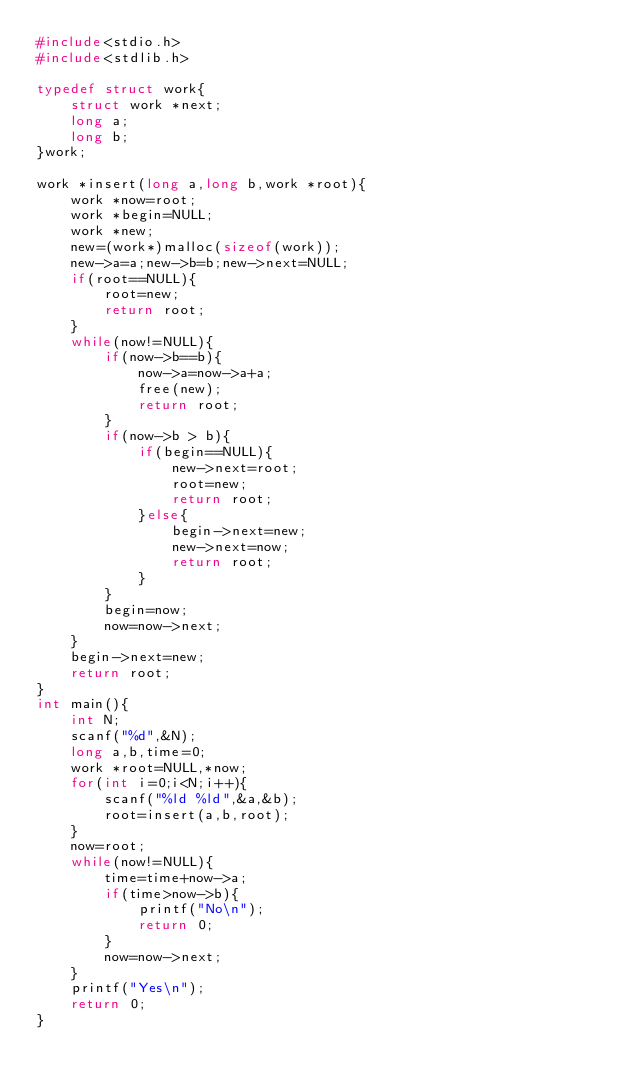Convert code to text. <code><loc_0><loc_0><loc_500><loc_500><_C_>#include<stdio.h>
#include<stdlib.h>

typedef struct work{
    struct work *next;
    long a;
    long b;
}work;

work *insert(long a,long b,work *root){
    work *now=root;
    work *begin=NULL;
    work *new;
    new=(work*)malloc(sizeof(work));
    new->a=a;new->b=b;new->next=NULL;
    if(root==NULL){
        root=new;
        return root;
    }
    while(now!=NULL){
        if(now->b==b){
            now->a=now->a+a;
            free(new);
            return root;
        }
        if(now->b > b){
            if(begin==NULL){
                new->next=root;
                root=new;
                return root;
            }else{
                begin->next=new;
                new->next=now;
                return root;
            }
        }
        begin=now;
        now=now->next;
    }
    begin->next=new;
    return root;
}
int main(){
    int N;
    scanf("%d",&N);
    long a,b,time=0;
    work *root=NULL,*now;
    for(int i=0;i<N;i++){
        scanf("%ld %ld",&a,&b);
        root=insert(a,b,root);
    }
    now=root;
    while(now!=NULL){
        time=time+now->a;
        if(time>now->b){
            printf("No\n");
            return 0;
        }
        now=now->next;
    }
    printf("Yes\n");
    return 0;
}</code> 